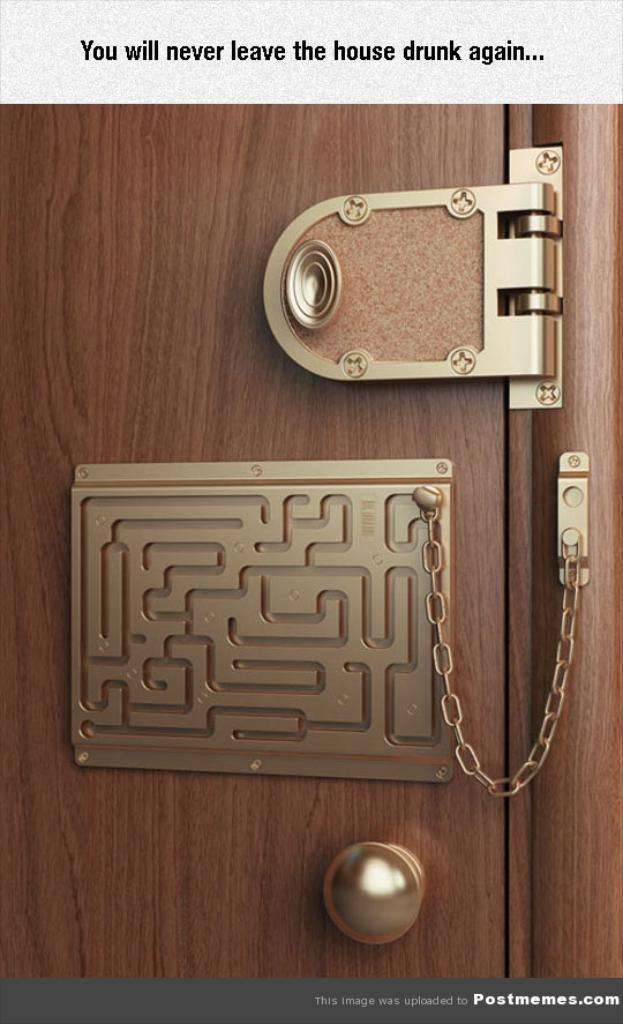What type of material is the wooden object made of in the image? The wooden object in the image is made of wood. What part of a door might the door handle be attached to? The door handle in the image might be attached to a door. What is the chain used for in the image? The chain in the image is used for an unspecified purpose. Can you describe the unspecified objects in the image? Unfortunately, the facts provided do not give any details about the unspecified objects in the image. What is the text in the image conveying? The facts provided do not give any details about the text in the image. What type of cabbage is being used as a doorstop in the image? There is no cabbage present in the image, and therefore it cannot be used as a doorstop. What grade did the mother receive on her report card in the image? There is no mother or report card present in the image, so this question cannot be answered. 